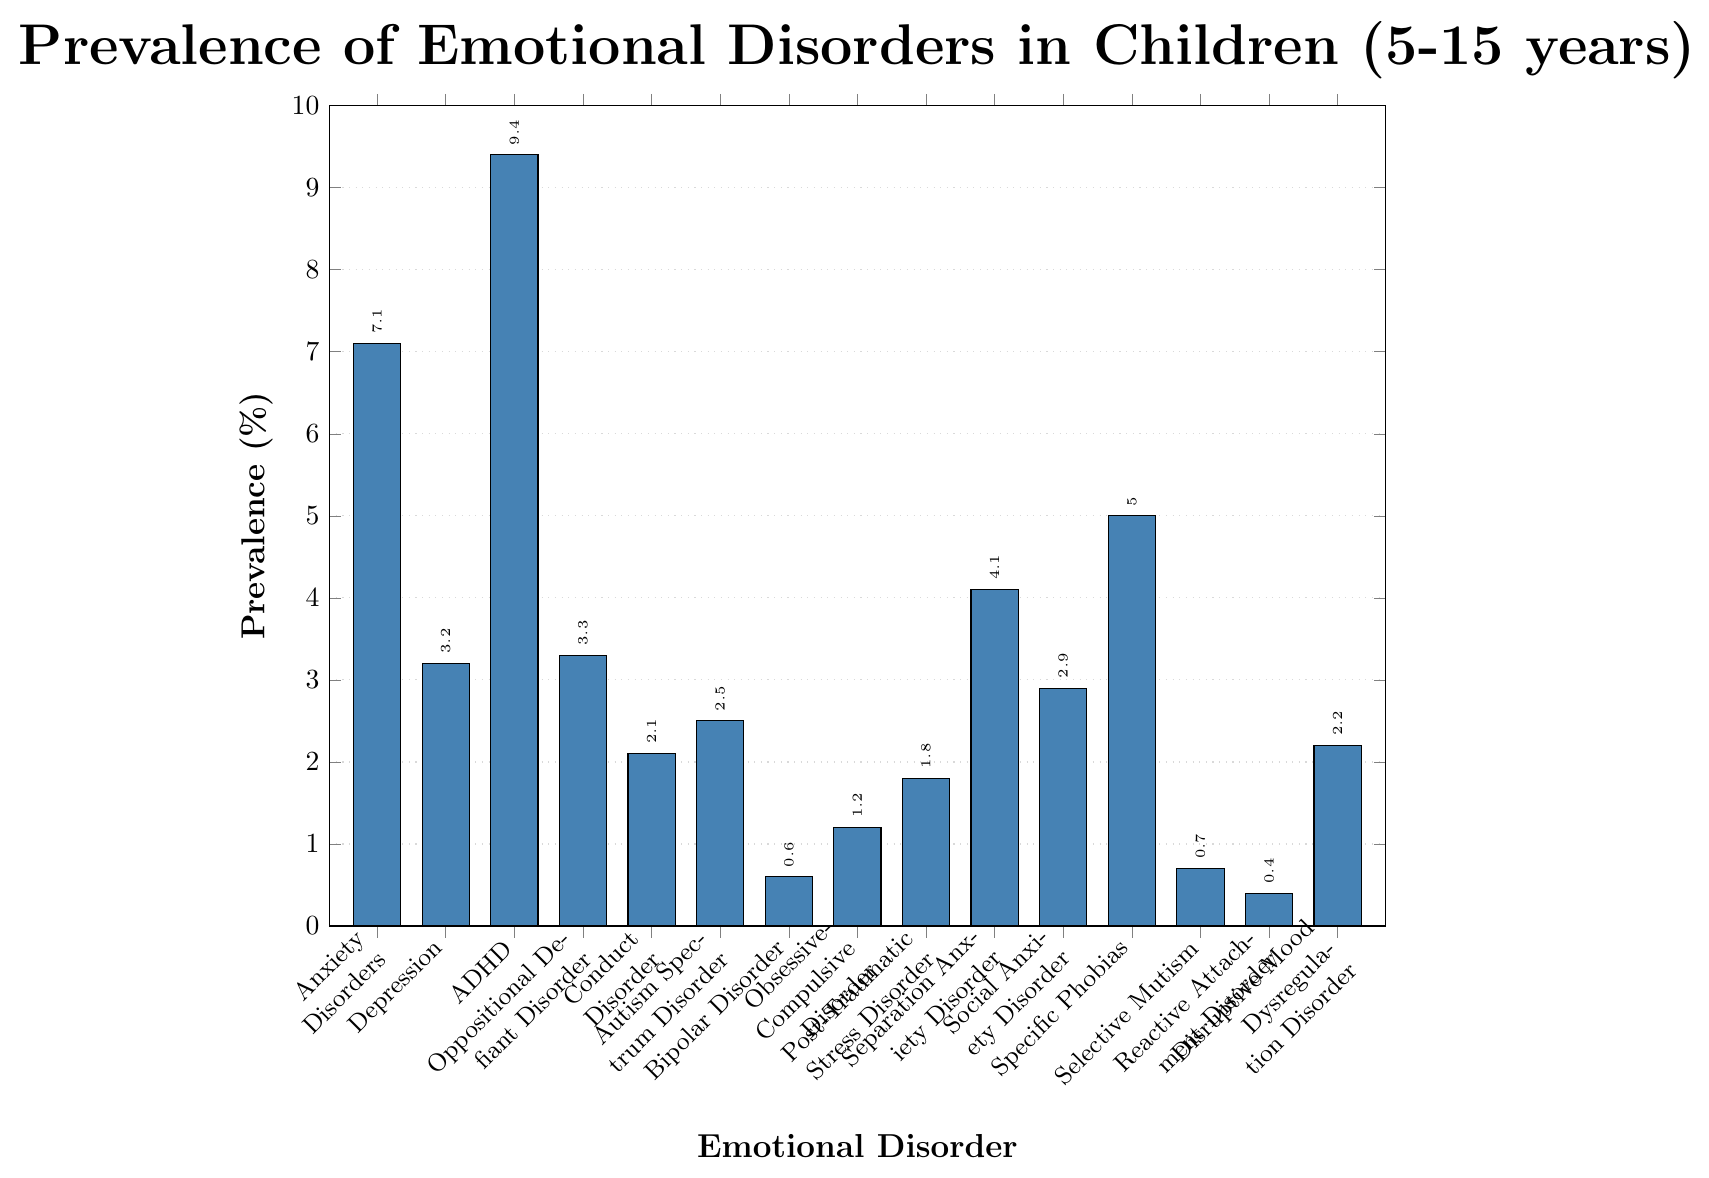What emotional disorder has the highest prevalence among children aged 5-15? The figure shows that ADHD has the highest bar and the corresponding value is 9.4%.
Answer: ADHD Which two disorders have a prevalence of less than 1%? By looking at the height of the bars, we see that Bipolar Disorder (0.6%) and Reactive Attachment Disorder (0.4%) have a prevalence of less than 1%.
Answer: Bipolar Disorder, Reactive Attachment Disorder How does the prevalence of Depression compare to Social Anxiety Disorder? The figure shows that the bar for Depression is labeled with 3.2%, while the bar for Social Anxiety Disorder is labeled with 2.9%. Therefore, Depression has a slightly higher prevalence than Social Anxiety Disorder.
Answer: Depression is higher What is the sum of the prevalence of Autism Spectrum Disorder and Specific Phobias? The figure indicates that Autism Spectrum Disorder has a prevalence of 2.5% and Specific Phobias has a prevalence of 5.0%. The sum is \(2.5 + 5.0 = 7.5\%).
Answer: 7.5% Which disorder has the closest prevalence to Separation Anxiety Disorder? The figure shows that Separation Anxiety Disorder has a prevalence of 4.1%. Oppositional Defiant Disorder, with a prevalence of 3.3%, is the closest in value among the other disorders.
Answer: Oppositional Defiant Disorder What is the average prevalence of Conduct Disorder, Obsessive-Compulsive Disorder, and Post-Traumatic Stress Disorder? The prevalences are 2.1% (Conduct Disorder), 1.2% (Obsessive-Compulsive Disorder), and 1.8% (Post-Traumatic Stress Disorder). Adding these gives \(2.1 + 1.2 + 1.8 = 5.1\). The average is \(5.1/3 = 1.7\%).
Answer: 1.7% Is the prevalence of Specific Phobias greater than twice the prevalence of Selective Mutism? Specific Phobias have a prevalence of 5.0% and Selective Mutism has a prevalence of 0.7%. Twice the prevalence of Selective Mutism is \(2 \times 0.7 = 1.4\). Since 5.0% is greater than 1.4%, the answer is yes.
Answer: Yes Which emotional disorder has a prevalence closest to 3%? By examining the bars, Social Anxiety Disorder has a prevalence of 2.9%, which is closest to 3% among all the listed disorders.
Answer: Social Anxiety Disorder What is the prevalence range (difference between highest and lowest prevalences) among the listed disorders? The highest prevalence is 9.4% (ADHD) and the lowest is 0.4% (Reactive Attachment Disorder). The range is \(9.4 - 0.4 = 9.0\%).
Answer: 9.0% Is there any disorder with an equal prevalence to Reactive Attachment Disorder? By observing the height of the bars, we see that Reactive Attachment Disorder has a unique prevalence of 0.4%, and no other disorder shares this exact value.
Answer: No 